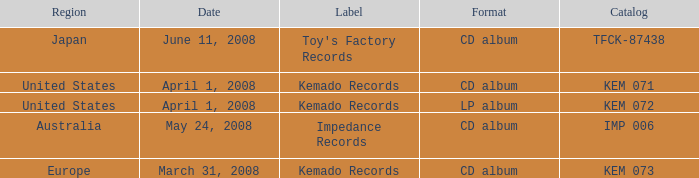Which Region has a Catalog of kem 072? United States. 